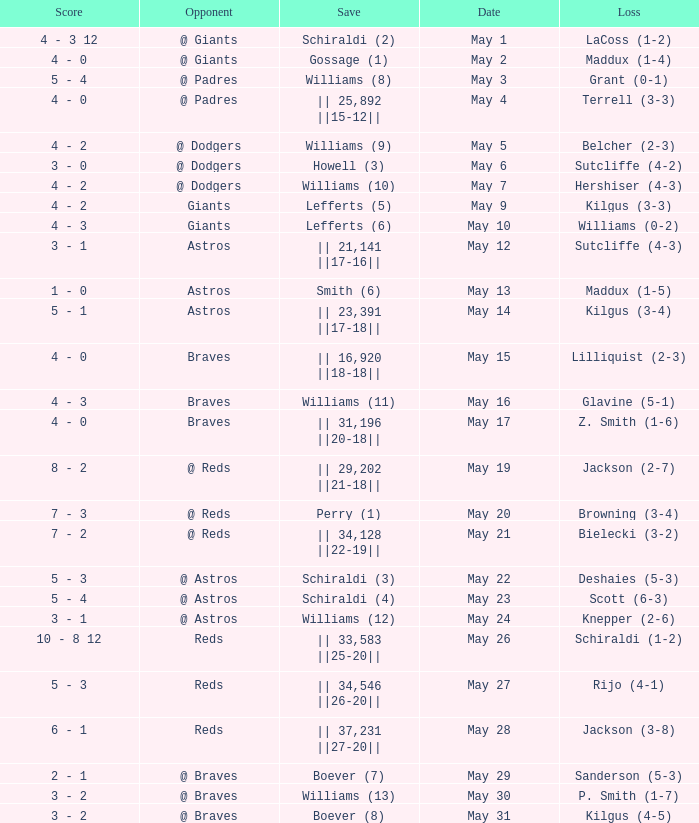Name the loss for may 1 LaCoss (1-2). 